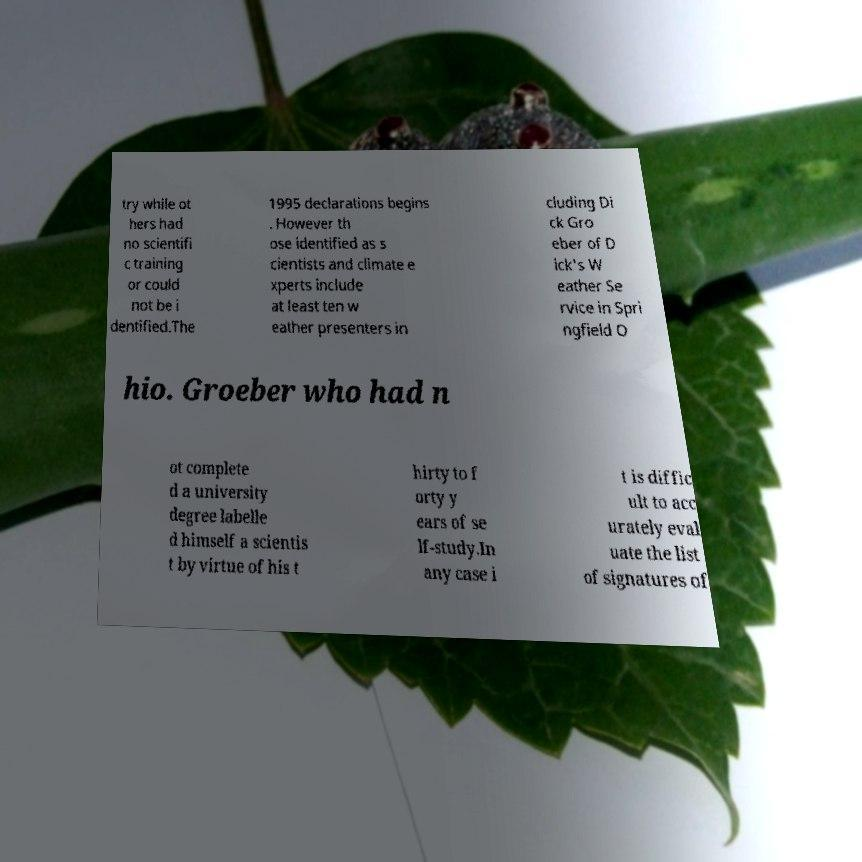Could you assist in decoding the text presented in this image and type it out clearly? try while ot hers had no scientifi c training or could not be i dentified.The 1995 declarations begins . However th ose identified as s cientists and climate e xperts include at least ten w eather presenters in cluding Di ck Gro eber of D ick's W eather Se rvice in Spri ngfield O hio. Groeber who had n ot complete d a university degree labelle d himself a scientis t by virtue of his t hirty to f orty y ears of se lf-study.In any case i t is diffic ult to acc urately eval uate the list of signatures of 